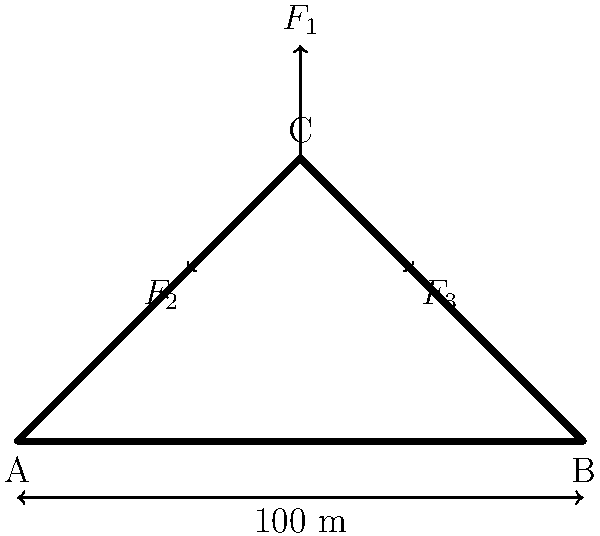As part of a historical preservation project, you're assessing an old bridge's structural integrity. The simplified force diagram above represents the bridge, where $F_1$ is the vertical load, and $F_2$ and $F_3$ are the reaction forces at supports A and B, respectively. If $F_1 = 200$ kN and the angle between $F_2$ and the horizontal is 30°, calculate the magnitude of $F_3$ to ensure the bridge is in equilibrium. To solve this problem, we'll use the principles of static equilibrium. The steps are as follows:

1) For a system in equilibrium, the sum of forces in all directions must equal zero.

2) We'll consider the x and y components separately:

   $$\sum F_x = 0$$ and $$\sum F_y = 0$$

3) From the diagram, we can deduce:
   - $F_2$ has components in both x and y directions
   - $F_3$ is purely in the x-direction
   - $F_1$ is purely in the y-direction

4) Let's break $F_2$ into its components:
   - $F_{2x} = F_2 \cos(30°)$
   - $F_{2y} = F_2 \sin(30°)$

5) Now, we can write our equilibrium equations:

   $$\sum F_x = 0: F_{2x} - F_3 = 0$$
   $$\sum F_y = 0: F_{2y} - F_1 = 0$$

6) From the y-direction equation:
   $$F_2 \sin(30°) = 200 \text{ kN}$$
   $$F_2 = \frac{200}{\sin(30°)} = 400 \text{ kN}$$

7) Now we can find $F_{2x}$:
   $$F_{2x} = 400 \cos(30°) = 346.41 \text{ kN}$$

8) Finally, from the x-direction equation:
   $$F_3 = F_{2x} = 346.41 \text{ kN}$$

Therefore, the magnitude of $F_3$ is 346.41 kN.
Answer: 346.41 kN 